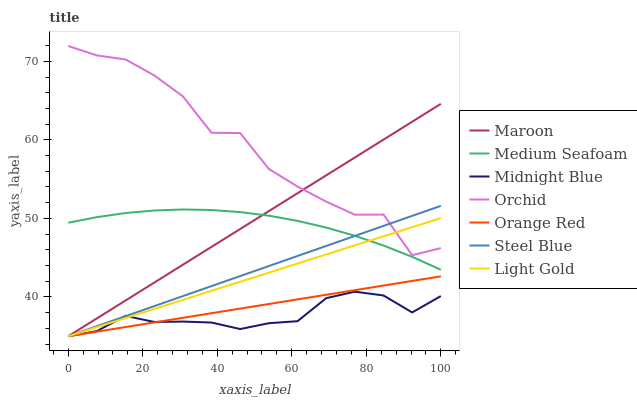Does Midnight Blue have the minimum area under the curve?
Answer yes or no. Yes. Does Orchid have the maximum area under the curve?
Answer yes or no. Yes. Does Steel Blue have the minimum area under the curve?
Answer yes or no. No. Does Steel Blue have the maximum area under the curve?
Answer yes or no. No. Is Steel Blue the smoothest?
Answer yes or no. Yes. Is Orchid the roughest?
Answer yes or no. Yes. Is Maroon the smoothest?
Answer yes or no. No. Is Maroon the roughest?
Answer yes or no. No. Does Midnight Blue have the lowest value?
Answer yes or no. Yes. Does Medium Seafoam have the lowest value?
Answer yes or no. No. Does Orchid have the highest value?
Answer yes or no. Yes. Does Steel Blue have the highest value?
Answer yes or no. No. Is Midnight Blue less than Orchid?
Answer yes or no. Yes. Is Orchid greater than Medium Seafoam?
Answer yes or no. Yes. Does Steel Blue intersect Medium Seafoam?
Answer yes or no. Yes. Is Steel Blue less than Medium Seafoam?
Answer yes or no. No. Is Steel Blue greater than Medium Seafoam?
Answer yes or no. No. Does Midnight Blue intersect Orchid?
Answer yes or no. No. 